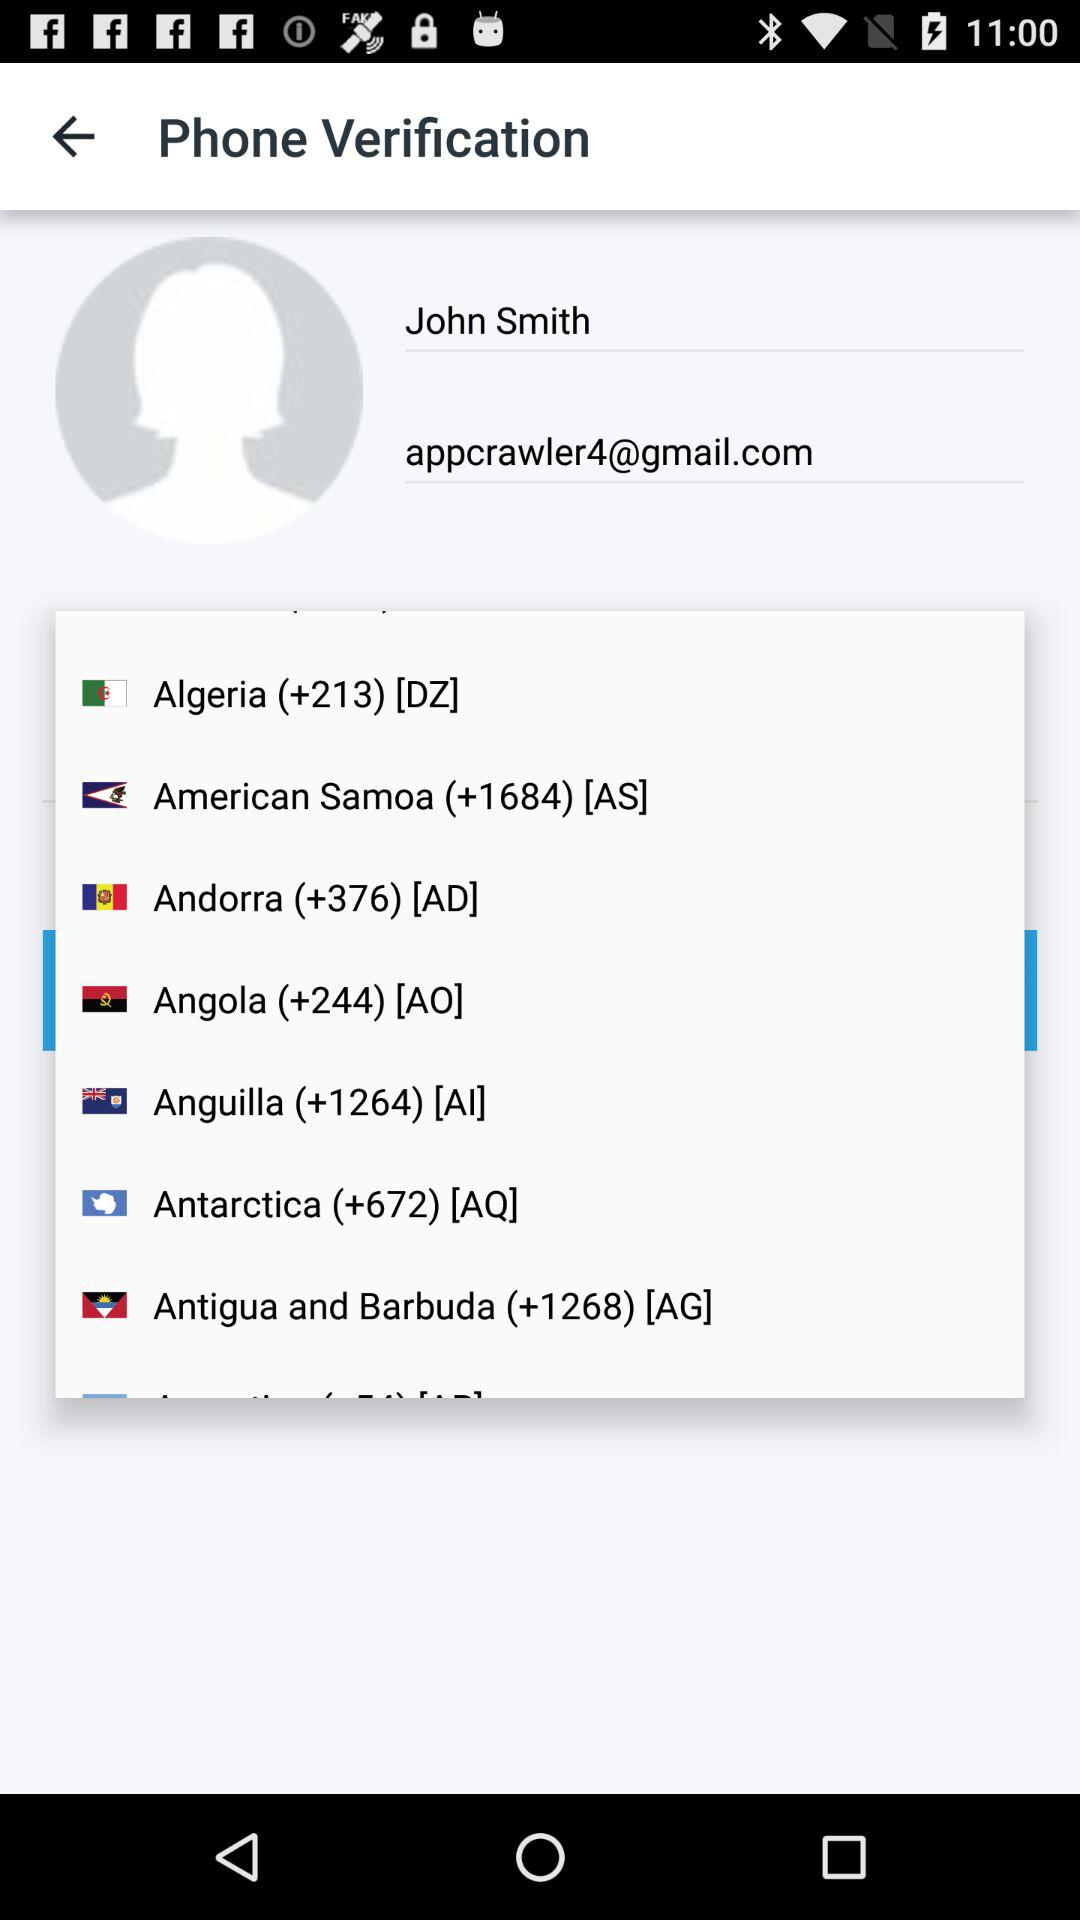What is the country code for Andorra? The country code is "(+376)". 